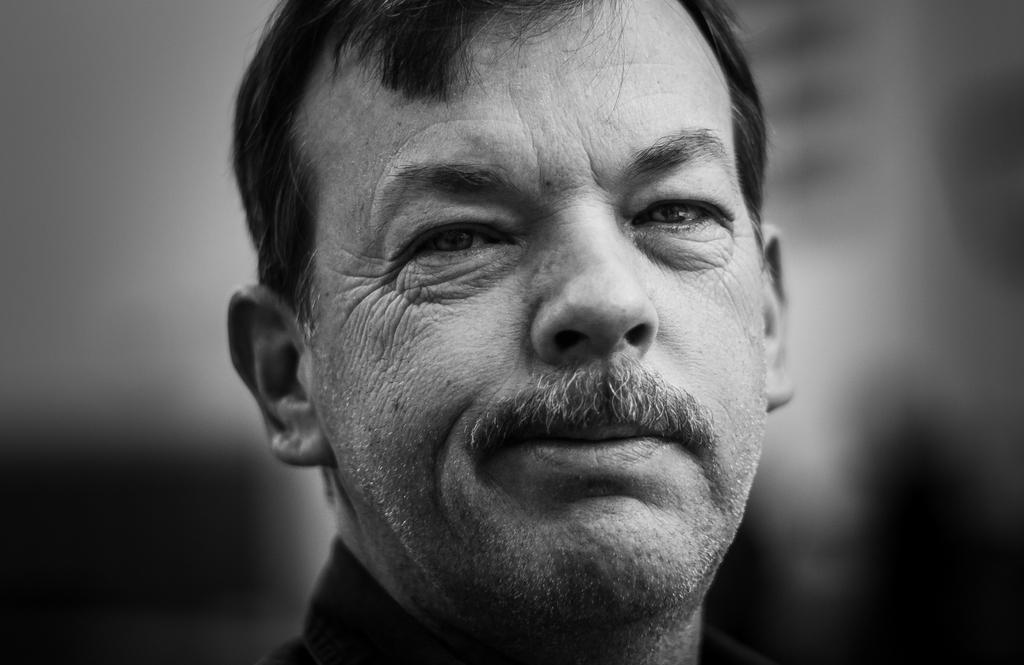What is the main subject of the image? The main subject of the image is the face of a man. What color scheme is used in the image? The image is in black and white color. How many giants are visible in the image? There are no giants present in the image; it features the face of a man. What type of wing is shown on the man's back in the image? There is no wing present on the man's back in the image. 